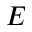Convert formula to latex. <formula><loc_0><loc_0><loc_500><loc_500>E</formula> 